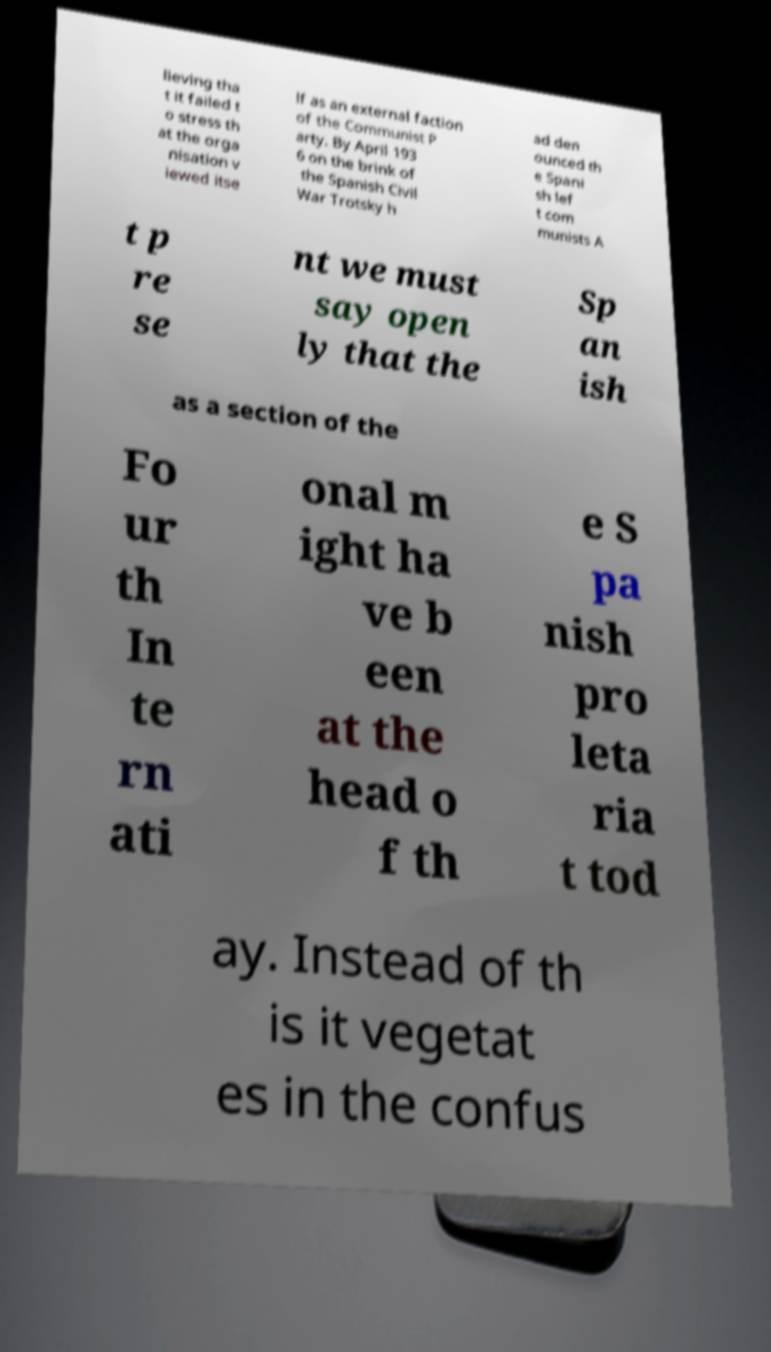There's text embedded in this image that I need extracted. Can you transcribe it verbatim? lieving tha t it failed t o stress th at the orga nisation v iewed itse lf as an external faction of the Communist P arty. By April 193 6 on the brink of the Spanish Civil War Trotsky h ad den ounced th e Spani sh lef t com munists A t p re se nt we must say open ly that the Sp an ish as a section of the Fo ur th In te rn ati onal m ight ha ve b een at the head o f th e S pa nish pro leta ria t tod ay. Instead of th is it vegetat es in the confus 